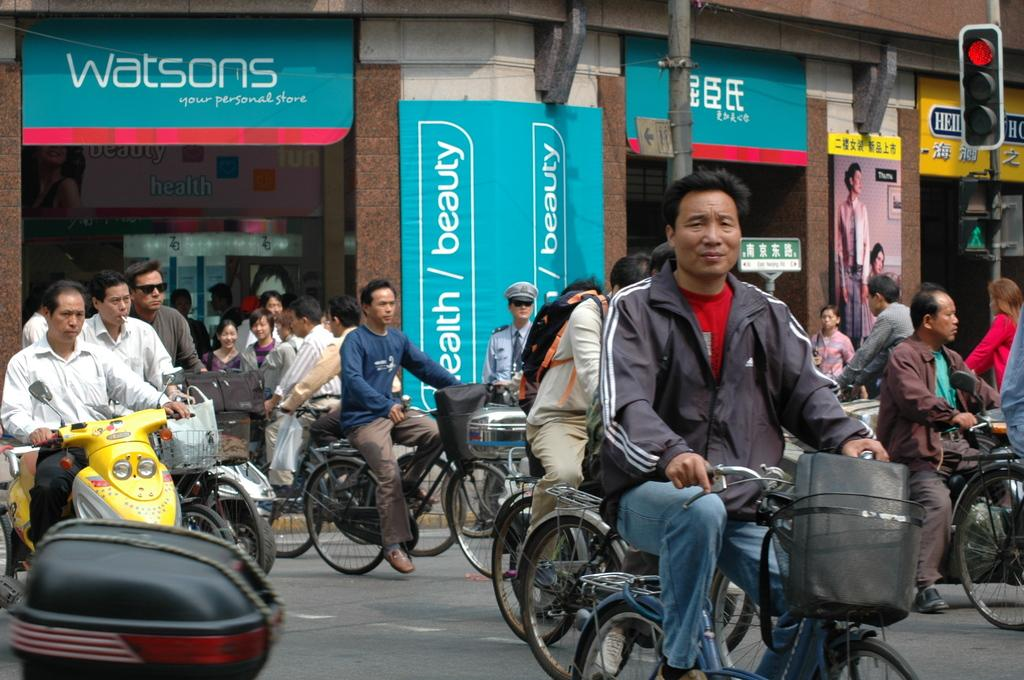What are the people in the image doing? There is a group of people riding a bicycle on the road. What else can be seen in the image besides the bicycle? There is a man riding a motorcycle. Where is the man on the motorcycle positioned in the image? The man on the motorcycle is on the left side. What is present on the right side of the image? There is a traffic signal pole on the right side. How does the earthquake affect the people riding the bicycle in the image? There is no earthquake present in the image; it only shows a group of people riding a bicycle and a man on a motorcycle. 